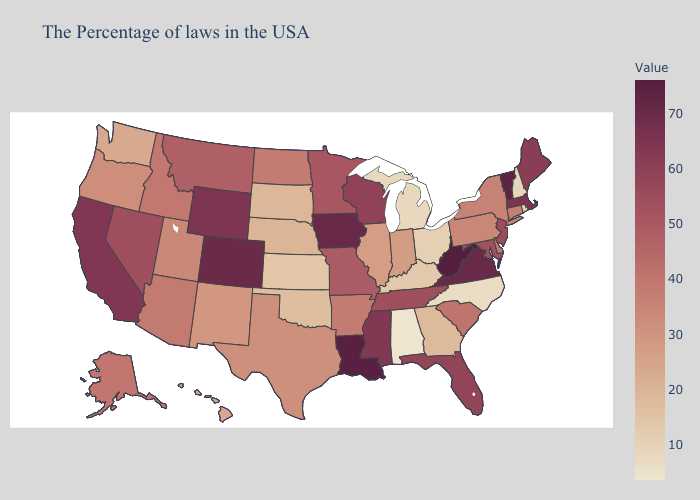Among the states that border Arizona , which have the highest value?
Give a very brief answer. Colorado. Among the states that border Delaware , which have the highest value?
Quick response, please. New Jersey. Does Wyoming have the lowest value in the West?
Answer briefly. No. 